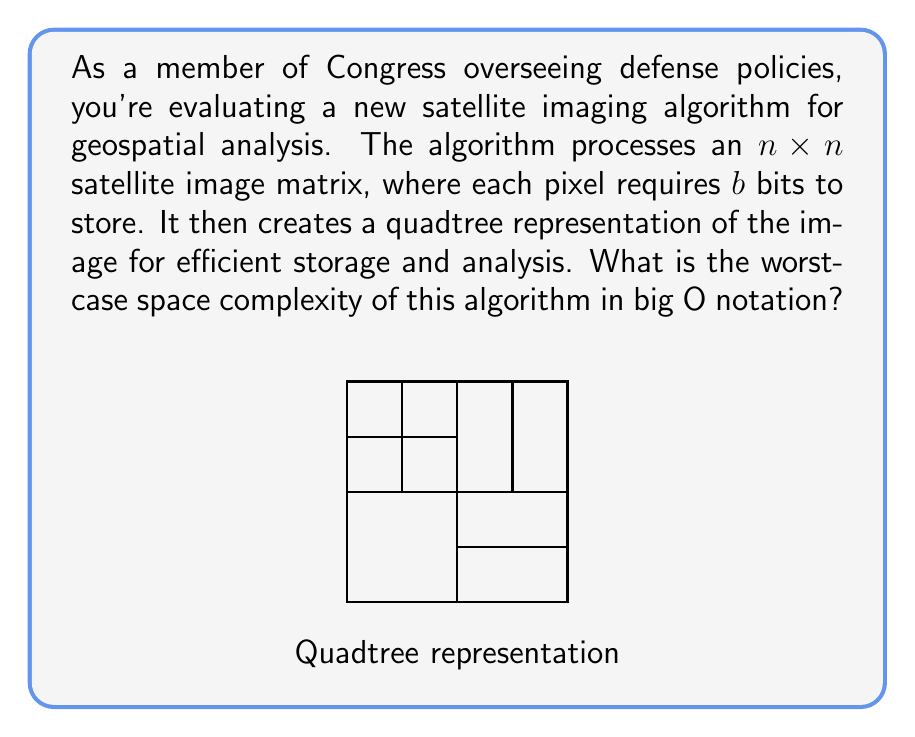Could you help me with this problem? To determine the space complexity, let's analyze the algorithm step-by-step:

1) Initial storage:
   - The original image requires $n^2 \cdot b$ bits to store.

2) Quadtree construction:
   - In the worst case, the quadtree will have a depth of $\log_4(n^2) = \log_2(n)$ levels.
   - At each level, we potentially store up to $n^2$ nodes (in the case of a completely non-uniform image).
   - Each node in the quadtree typically requires a fixed amount of space, let's call it $c$.

3) Total space for quadtree:
   - Worst-case number of nodes: $\sum_{i=0}^{\log_2(n)} n^2 = n^2(\log_2(n) + 1)$
   - Total space: $cn^2(\log_2(n) + 1)$

4) Combining original image and quadtree:
   - Total space: $n^2b + cn^2(\log_2(n) + 1)$

5) Simplifying:
   - Factor out $n^2$: $n^2(b + c(\log_2(n) + 1))$
   - The dominant term as $n$ grows is $n^2\log_2(n)$

Therefore, the worst-case space complexity is $O(n^2\log n)$.
Answer: $O(n^2\log n)$ 